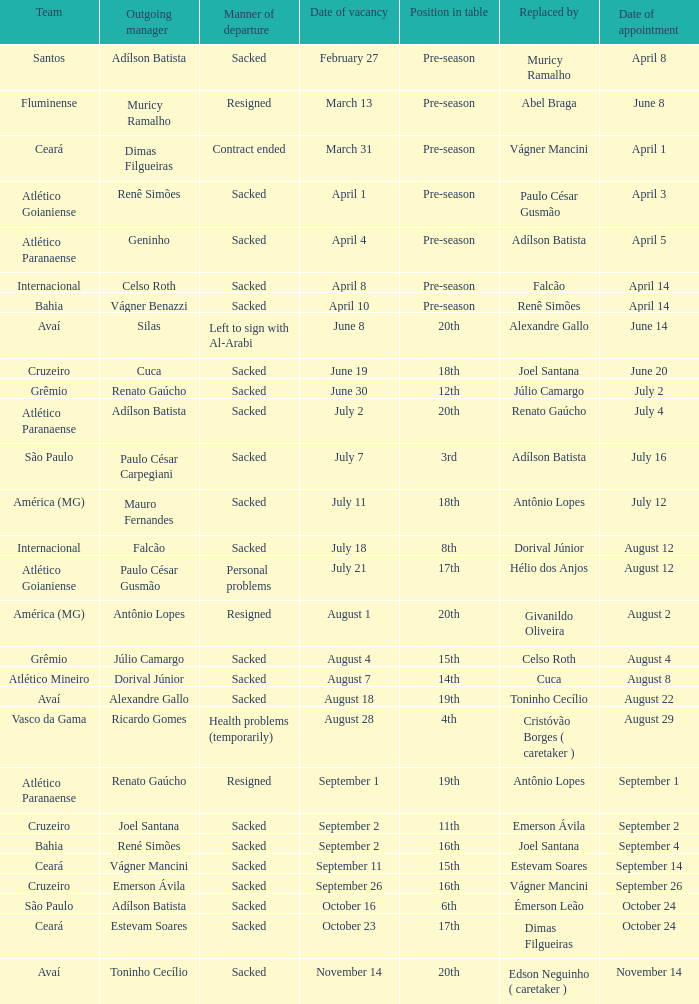Who was the new Santos manager? Muricy Ramalho. 